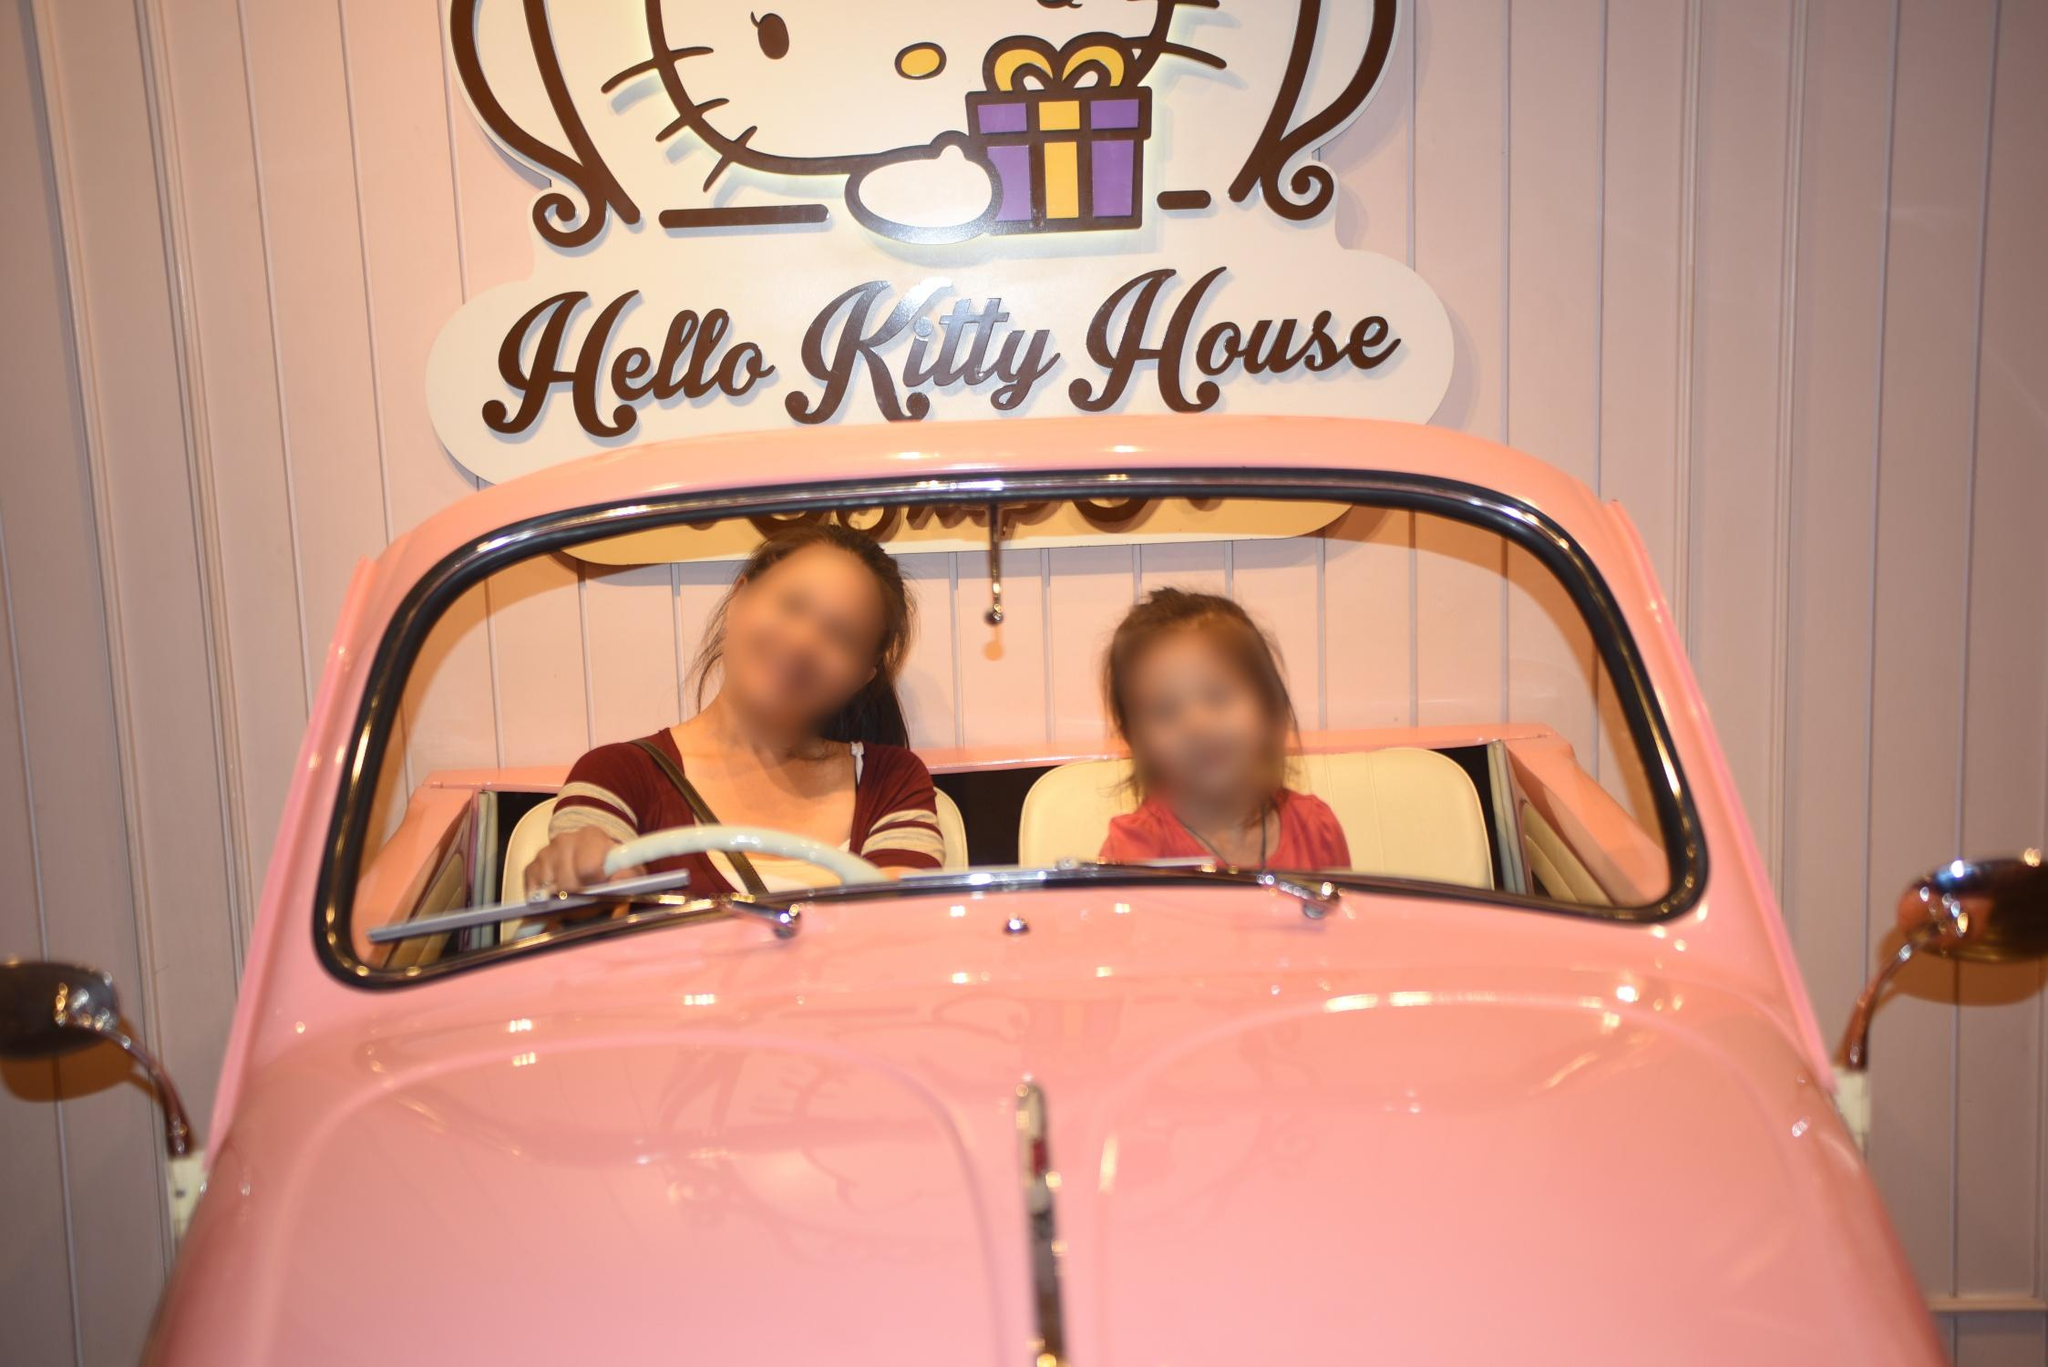What's the significance of the pink color scheme in the image? The pink color scheme seen in the image is emblematic of the Hello Kitty brand. Pink is often associated with the character and signifies a cute, feminine, and friendly aesthetic. The particular shade of pink used here contributes to the fun and whimsical ambiance that attracts Hello Kitty enthusiasts. 